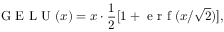<formula> <loc_0><loc_0><loc_500><loc_500>G E L U ( x ) = x \cdot \frac { 1 } { 2 } [ 1 + e r f ( x / \sqrt { 2 } ) ] ,</formula> 